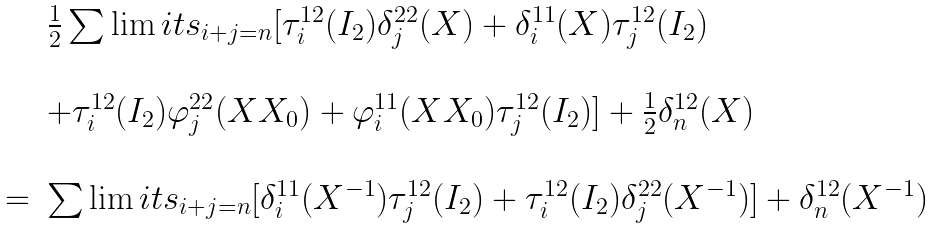<formula> <loc_0><loc_0><loc_500><loc_500>\begin{array} { r c l } & & \frac { 1 } { 2 } \sum \lim i t s _ { i + j = n } [ \tau _ { i } ^ { 1 2 } ( I _ { 2 } ) \delta _ { j } ^ { 2 2 } ( X ) + \delta _ { i } ^ { 1 1 } ( X ) \tau _ { j } ^ { 1 2 } ( I _ { 2 } ) \\ \\ & & + \tau _ { i } ^ { 1 2 } ( I _ { 2 } ) \varphi _ { j } ^ { 2 2 } ( X X _ { 0 } ) + \varphi _ { i } ^ { 1 1 } ( X X _ { 0 } ) \tau _ { j } ^ { 1 2 } ( I _ { 2 } ) ] + \frac { 1 } { 2 } \delta _ { n } ^ { 1 2 } ( X ) \\ \\ & = & \sum \lim i t s _ { i + j = n } [ \delta _ { i } ^ { 1 1 } ( X ^ { - 1 } ) \tau _ { j } ^ { 1 2 } ( I _ { 2 } ) + \tau _ { i } ^ { 1 2 } ( I _ { 2 } ) \delta _ { j } ^ { 2 2 } ( X ^ { - 1 } ) ] + \delta _ { n } ^ { 1 2 } ( X ^ { - 1 } ) \end{array}</formula> 